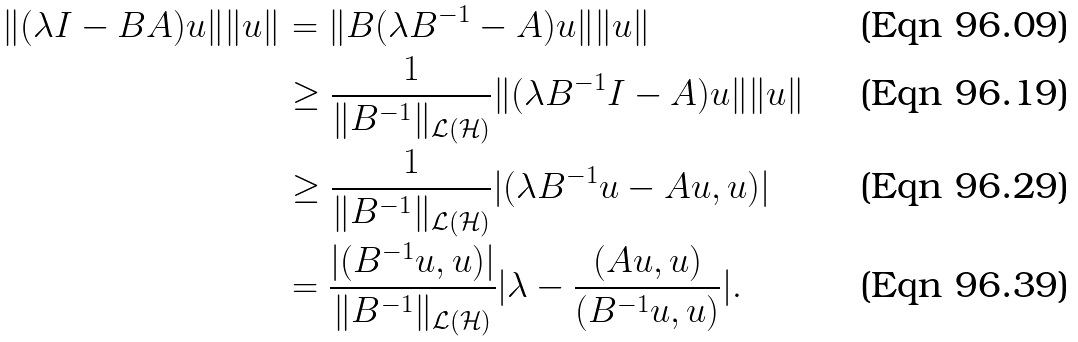<formula> <loc_0><loc_0><loc_500><loc_500>\| ( \lambda I - B A ) u \| \| u \| & = \| B ( \lambda B ^ { - 1 } - A ) u \| \| u \| \\ & \geq \frac { 1 } { \| B ^ { - 1 } \| _ { \mathcal { L ( H ) } } } \| ( \lambda B ^ { - 1 } I - A ) u \| \| u \| \\ & \geq \frac { 1 } { \| B ^ { - 1 } \| _ { \mathcal { L ( H ) } } } | ( \lambda B ^ { - 1 } u - A u , u ) | \\ & = \frac { | ( B ^ { - 1 } u , u ) | } { \| B ^ { - 1 } \| _ { \mathcal { L ( H ) } } } | \lambda - \frac { ( A u , u ) } { ( B ^ { - 1 } u , u ) } | .</formula> 